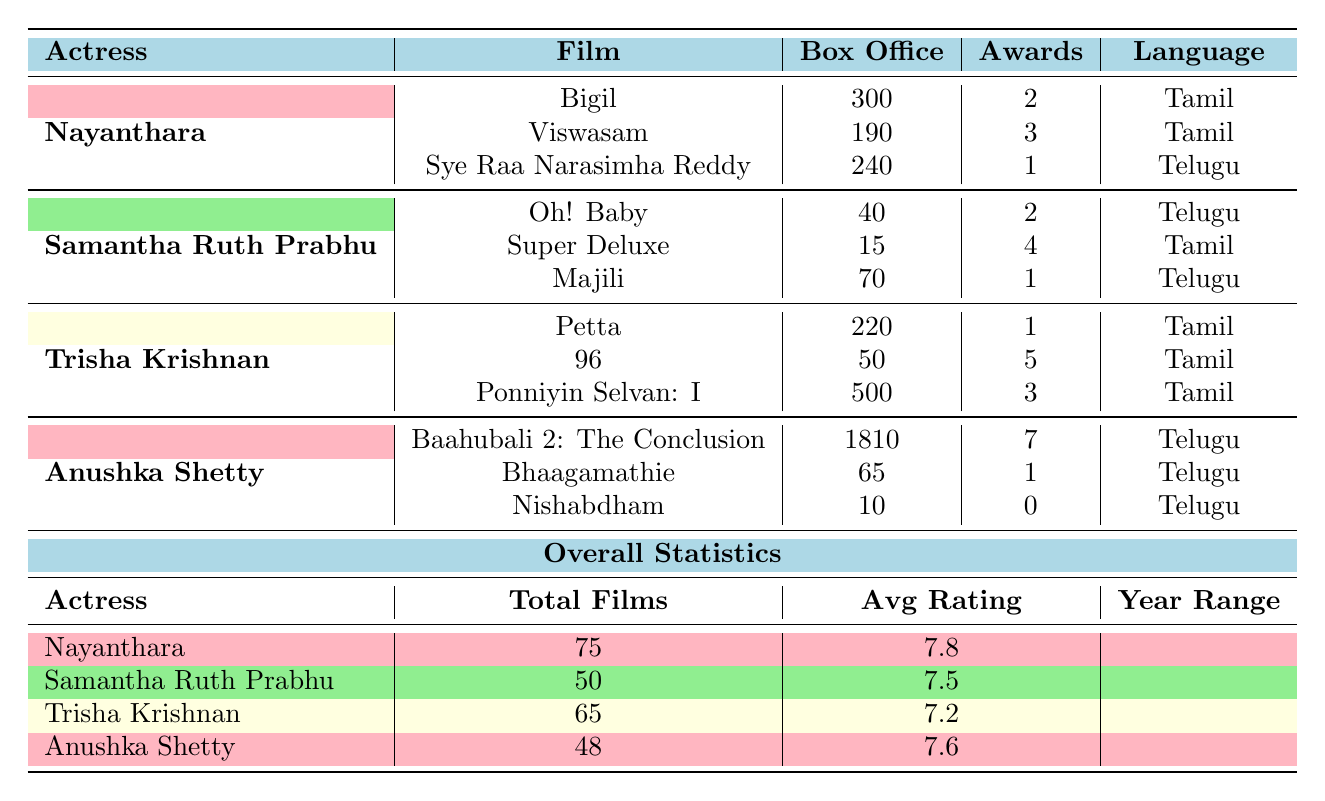What is the title of Nayanthara's film with the highest box office collection? Among Nayanthara's films listed, "Bigil" has the highest box office collection of 300 crores INR.
Answer: Bigil How many awards did Nayanthara win for her film "Viswasam"? The film "Viswasam" earned Nayanthara 3 awards, as shown in the table.
Answer: 3 Which actress has the highest average rating? Looking at the average ratings of the actresses, Nayanthara has the highest average rating of 7.8.
Answer: 7.8 What is the total box office collection of Samantha Ruth Prabhu's films listed in the table? The total box office collection for Samantha's films is calculated by adding 40 + 15 + 70 = 125 crores INR.
Answer: 125 Who made more movies, Nayanthara or Trisha Krishnan? Nayanthara has made 75 films while Trisha Krishnan has made 65 films, so Nayanthara has made more movies.
Answer: Nayanthara Calculate the difference in total films between Anushka Shetty and Samantha Ruth Prabhu. Anushka Shetty has 48 films and Samantha has 50 films. The difference is 50 - 48 = 2 films.
Answer: 2 Did Nayanthara's films collectively earn more box office revenue than Anushka Shetty's films? Nayanthara’s films total 300 + 190 + 240 = 730 crores INR, while Anushka’s films total 1810 + 65 + 10 = 1885 crores INR. Thus, Nayanthara's films earned less.
Answer: No What is the average rating of Trisha Krishnan's films? The table shows that Trisha Krishnan's average rating is 7.2, which is directly provided.
Answer: 7.2 If you consider only the box office collections and awards, which actress had the best performing film overall? Anushka Shetty's "Baahubali 2" has a box office of 1810 crores INR and won 7 awards, making it the best performing film in terms of both metrics.
Answer: Anushka Shetty Which actress has the highest number of awards won among the listed films? Anushka Shetty won a total of 7 awards for her film "Baahubali 2", which is higher than any other actress’s award total in the table.
Answer: Anushka Shetty 